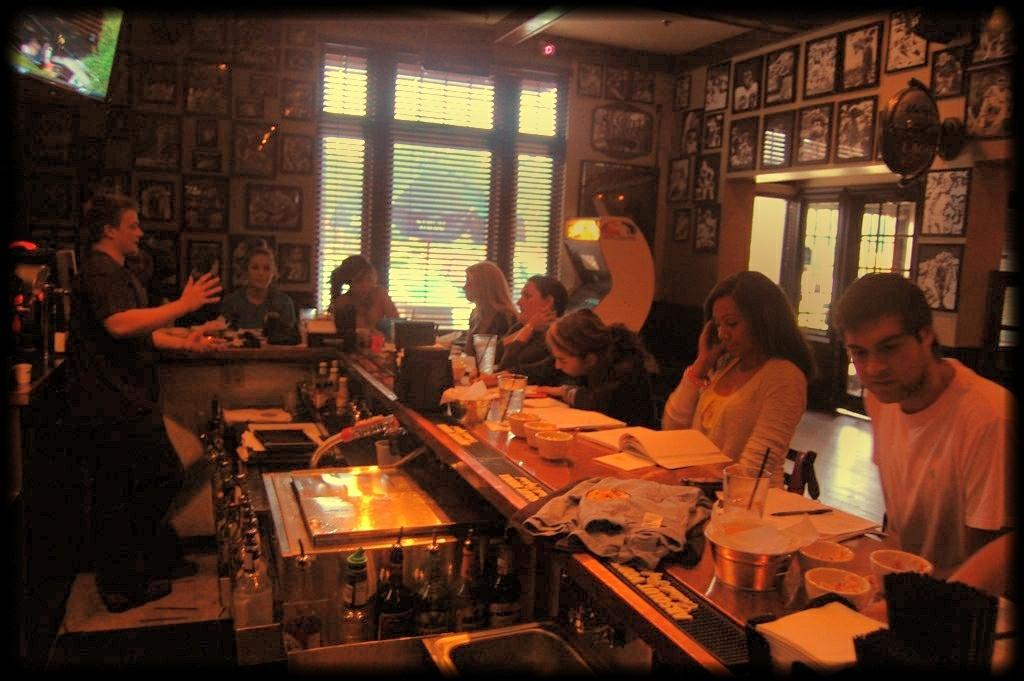How would you summarize this image in a sentence or two? In this image we can see some people sitting in front of the table and on the table we can see glasses, cups, bowls, clothes, books and also papers. On the left there is a person standing. Image also consists of many photo frames which are attached to the wall. We can also see the window. 